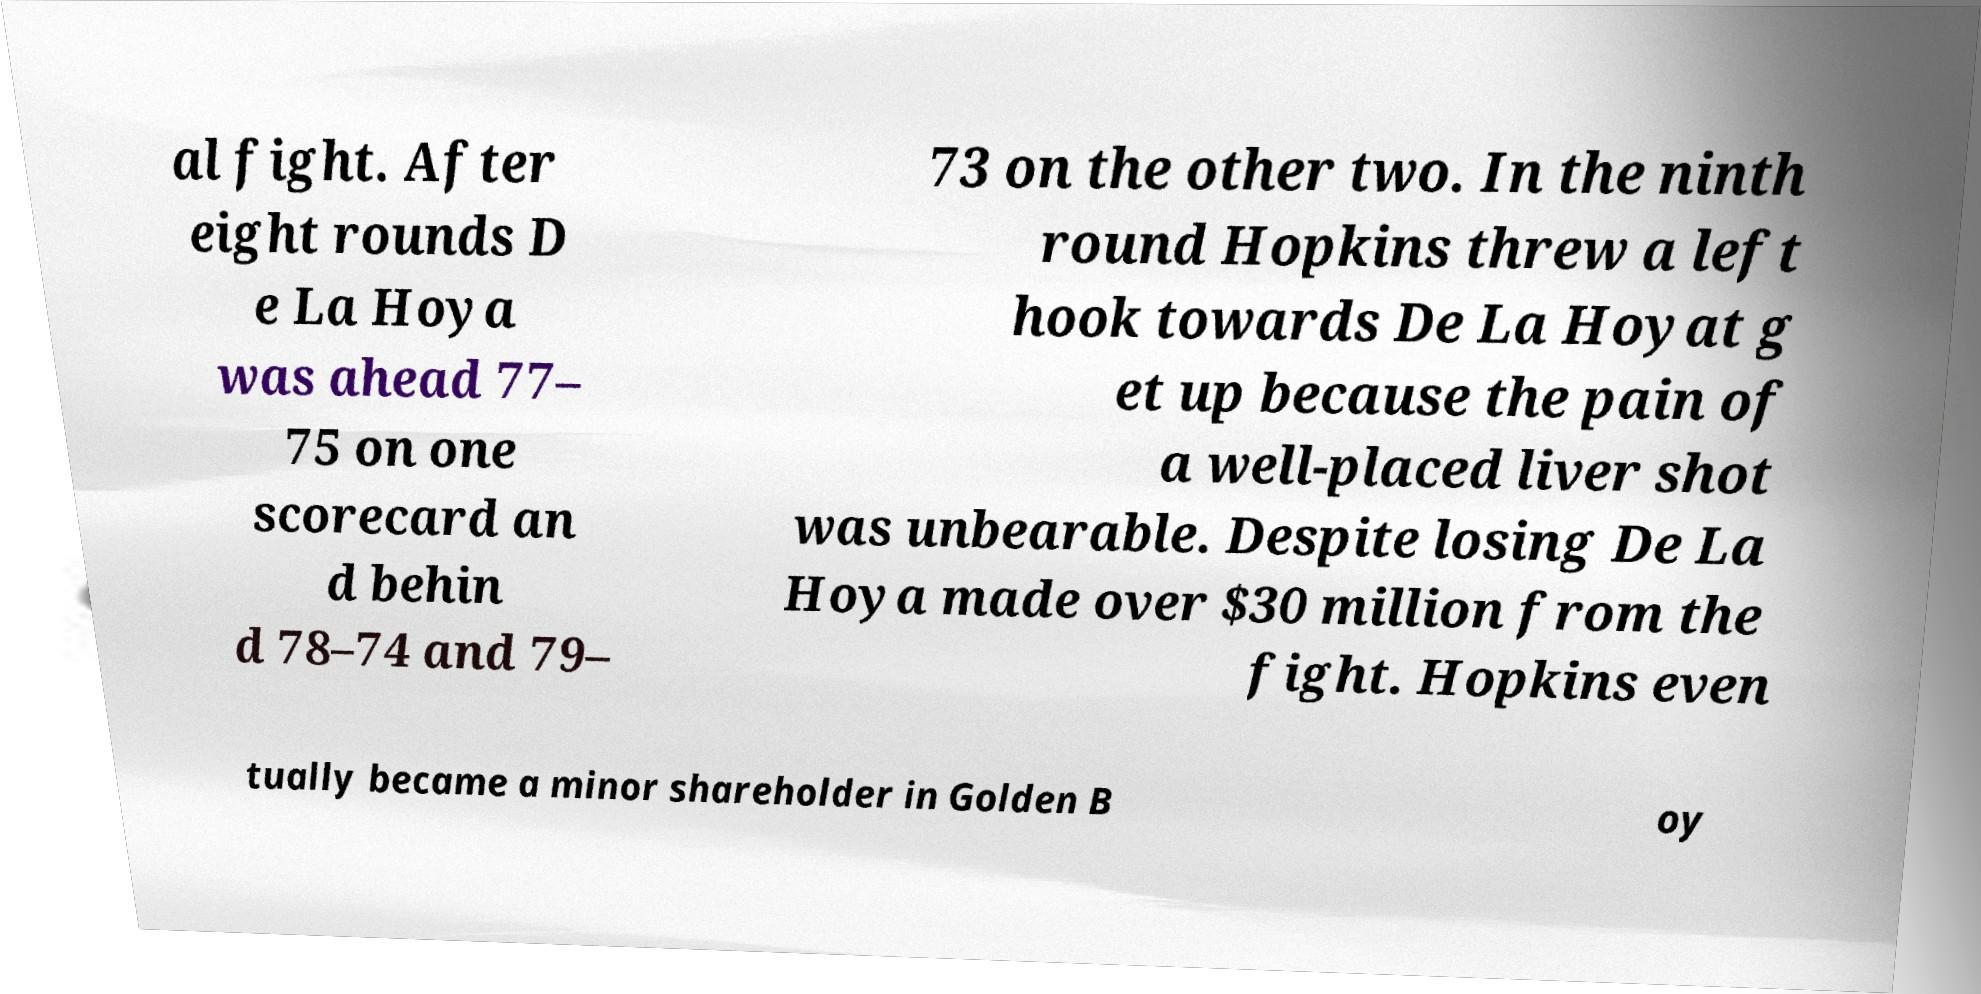There's text embedded in this image that I need extracted. Can you transcribe it verbatim? al fight. After eight rounds D e La Hoya was ahead 77– 75 on one scorecard an d behin d 78–74 and 79– 73 on the other two. In the ninth round Hopkins threw a left hook towards De La Hoyat g et up because the pain of a well-placed liver shot was unbearable. Despite losing De La Hoya made over $30 million from the fight. Hopkins even tually became a minor shareholder in Golden B oy 